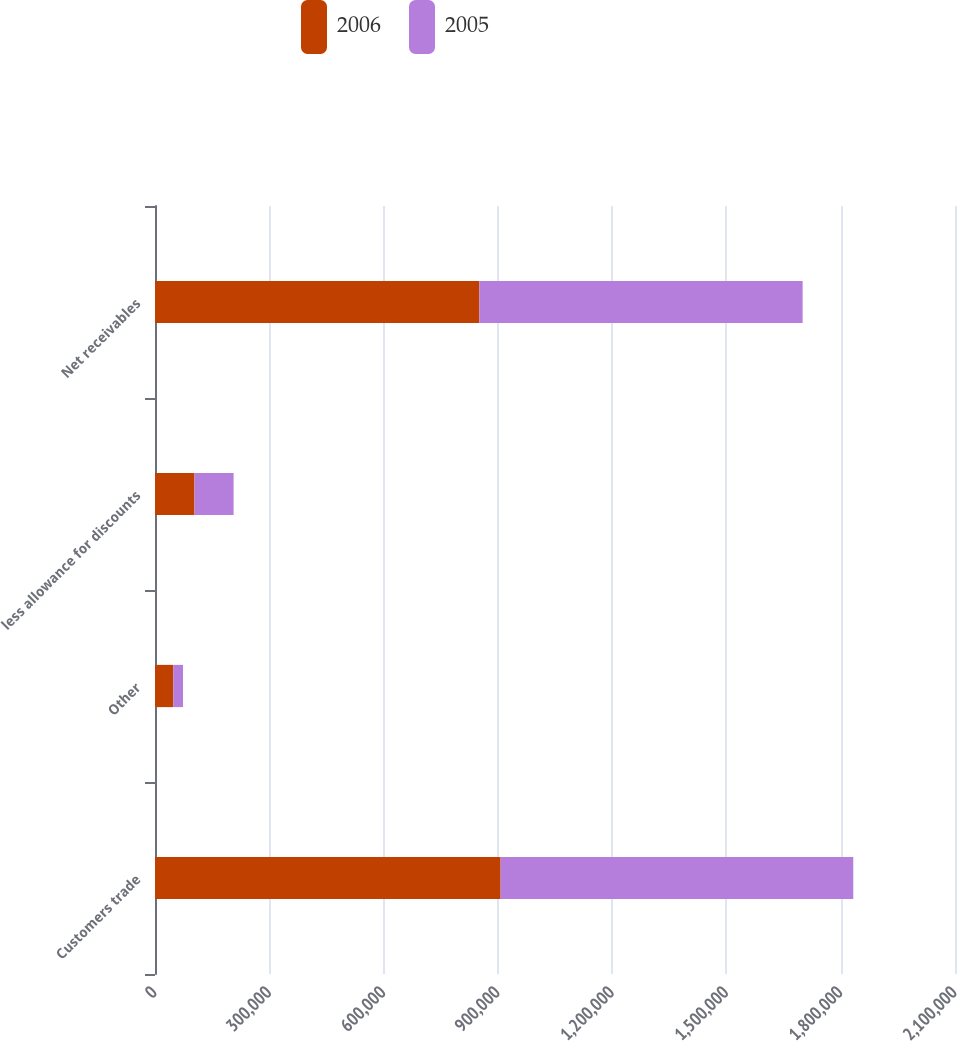<chart> <loc_0><loc_0><loc_500><loc_500><stacked_bar_chart><ecel><fcel>Customers trade<fcel>Other<fcel>less allowance for discounts<fcel>Net receivables<nl><fcel>2006<fcel>907244<fcel>47798<fcel>103614<fcel>851428<nl><fcel>2005<fcel>925714<fcel>25662<fcel>102710<fcel>848666<nl></chart> 